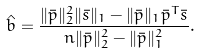<formula> <loc_0><loc_0><loc_500><loc_500>\hat { b } = \frac { \| \bar { p } \| _ { 2 } ^ { 2 } \| \bar { s } \| _ { 1 } - \| \bar { p } \| _ { 1 } \bar { p } ^ { T } \bar { s } } { n \| \bar { p } \| _ { 2 } ^ { 2 } - \| \bar { p } \| _ { 1 } ^ { 2 } } .</formula> 